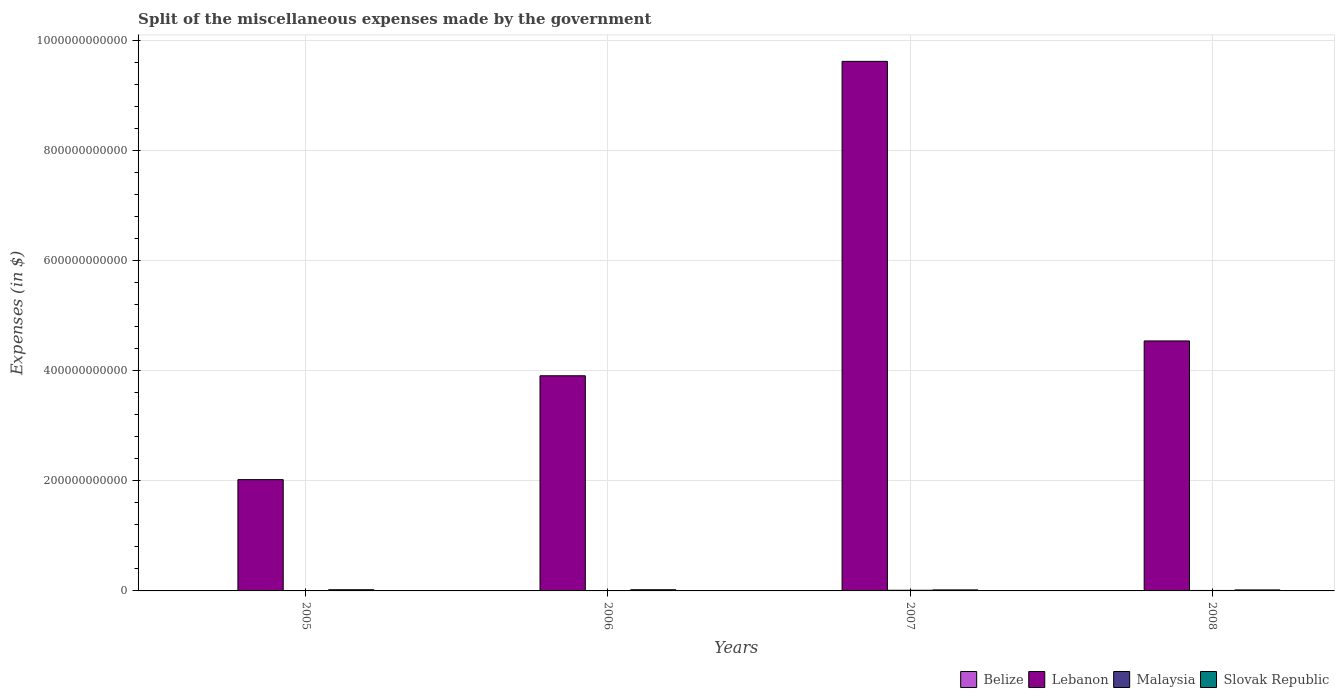How many different coloured bars are there?
Make the answer very short. 4. How many bars are there on the 2nd tick from the left?
Provide a succinct answer. 4. How many bars are there on the 4th tick from the right?
Provide a short and direct response. 4. What is the label of the 2nd group of bars from the left?
Make the answer very short. 2006. In how many cases, is the number of bars for a given year not equal to the number of legend labels?
Offer a terse response. 0. What is the miscellaneous expenses made by the government in Lebanon in 2006?
Offer a very short reply. 3.91e+11. Across all years, what is the maximum miscellaneous expenses made by the government in Slovak Republic?
Your answer should be compact. 2.17e+09. Across all years, what is the minimum miscellaneous expenses made by the government in Malaysia?
Keep it short and to the point. 3.43e+08. In which year was the miscellaneous expenses made by the government in Malaysia minimum?
Give a very brief answer. 2005. What is the total miscellaneous expenses made by the government in Belize in the graph?
Offer a terse response. 7.90e+07. What is the difference between the miscellaneous expenses made by the government in Lebanon in 2005 and that in 2008?
Provide a short and direct response. -2.52e+11. What is the difference between the miscellaneous expenses made by the government in Lebanon in 2007 and the miscellaneous expenses made by the government in Slovak Republic in 2005?
Ensure brevity in your answer.  9.61e+11. What is the average miscellaneous expenses made by the government in Malaysia per year?
Make the answer very short. 6.95e+08. In the year 2008, what is the difference between the miscellaneous expenses made by the government in Belize and miscellaneous expenses made by the government in Slovak Republic?
Your answer should be very brief. -1.83e+09. What is the ratio of the miscellaneous expenses made by the government in Lebanon in 2007 to that in 2008?
Offer a terse response. 2.12. Is the difference between the miscellaneous expenses made by the government in Belize in 2007 and 2008 greater than the difference between the miscellaneous expenses made by the government in Slovak Republic in 2007 and 2008?
Your answer should be very brief. Yes. What is the difference between the highest and the second highest miscellaneous expenses made by the government in Malaysia?
Your response must be concise. 3.48e+08. What is the difference between the highest and the lowest miscellaneous expenses made by the government in Lebanon?
Your answer should be compact. 7.61e+11. In how many years, is the miscellaneous expenses made by the government in Malaysia greater than the average miscellaneous expenses made by the government in Malaysia taken over all years?
Your answer should be very brief. 2. What does the 4th bar from the left in 2007 represents?
Your answer should be compact. Slovak Republic. What does the 1st bar from the right in 2006 represents?
Ensure brevity in your answer.  Slovak Republic. How many bars are there?
Your answer should be very brief. 16. What is the difference between two consecutive major ticks on the Y-axis?
Make the answer very short. 2.00e+11. How many legend labels are there?
Your response must be concise. 4. What is the title of the graph?
Your response must be concise. Split of the miscellaneous expenses made by the government. What is the label or title of the Y-axis?
Offer a terse response. Expenses (in $). What is the Expenses (in $) of Belize in 2005?
Give a very brief answer. 9.38e+06. What is the Expenses (in $) of Lebanon in 2005?
Ensure brevity in your answer.  2.02e+11. What is the Expenses (in $) in Malaysia in 2005?
Your answer should be compact. 3.43e+08. What is the Expenses (in $) in Slovak Republic in 2005?
Your response must be concise. 2.16e+09. What is the Expenses (in $) of Belize in 2006?
Keep it short and to the point. 3.63e+06. What is the Expenses (in $) of Lebanon in 2006?
Offer a terse response. 3.91e+11. What is the Expenses (in $) in Malaysia in 2006?
Your answer should be compact. 3.91e+08. What is the Expenses (in $) in Slovak Republic in 2006?
Ensure brevity in your answer.  2.17e+09. What is the Expenses (in $) of Belize in 2007?
Offer a terse response. 6.27e+07. What is the Expenses (in $) of Lebanon in 2007?
Give a very brief answer. 9.63e+11. What is the Expenses (in $) in Malaysia in 2007?
Provide a succinct answer. 1.20e+09. What is the Expenses (in $) of Slovak Republic in 2007?
Your response must be concise. 1.86e+09. What is the Expenses (in $) of Belize in 2008?
Your response must be concise. 3.21e+06. What is the Expenses (in $) of Lebanon in 2008?
Provide a succinct answer. 4.55e+11. What is the Expenses (in $) in Malaysia in 2008?
Provide a short and direct response. 8.49e+08. What is the Expenses (in $) in Slovak Republic in 2008?
Give a very brief answer. 1.84e+09. Across all years, what is the maximum Expenses (in $) in Belize?
Make the answer very short. 6.27e+07. Across all years, what is the maximum Expenses (in $) in Lebanon?
Offer a terse response. 9.63e+11. Across all years, what is the maximum Expenses (in $) of Malaysia?
Provide a short and direct response. 1.20e+09. Across all years, what is the maximum Expenses (in $) in Slovak Republic?
Make the answer very short. 2.17e+09. Across all years, what is the minimum Expenses (in $) of Belize?
Give a very brief answer. 3.21e+06. Across all years, what is the minimum Expenses (in $) in Lebanon?
Provide a succinct answer. 2.02e+11. Across all years, what is the minimum Expenses (in $) of Malaysia?
Keep it short and to the point. 3.43e+08. Across all years, what is the minimum Expenses (in $) of Slovak Republic?
Offer a terse response. 1.84e+09. What is the total Expenses (in $) in Belize in the graph?
Provide a succinct answer. 7.90e+07. What is the total Expenses (in $) in Lebanon in the graph?
Your answer should be compact. 2.01e+12. What is the total Expenses (in $) of Malaysia in the graph?
Offer a very short reply. 2.78e+09. What is the total Expenses (in $) in Slovak Republic in the graph?
Offer a very short reply. 8.03e+09. What is the difference between the Expenses (in $) of Belize in 2005 and that in 2006?
Ensure brevity in your answer.  5.75e+06. What is the difference between the Expenses (in $) of Lebanon in 2005 and that in 2006?
Provide a short and direct response. -1.89e+11. What is the difference between the Expenses (in $) in Malaysia in 2005 and that in 2006?
Your answer should be very brief. -4.78e+07. What is the difference between the Expenses (in $) of Slovak Republic in 2005 and that in 2006?
Provide a short and direct response. -7.93e+06. What is the difference between the Expenses (in $) of Belize in 2005 and that in 2007?
Your answer should be compact. -5.34e+07. What is the difference between the Expenses (in $) of Lebanon in 2005 and that in 2007?
Offer a very short reply. -7.61e+11. What is the difference between the Expenses (in $) of Malaysia in 2005 and that in 2007?
Ensure brevity in your answer.  -8.54e+08. What is the difference between the Expenses (in $) in Slovak Republic in 2005 and that in 2007?
Make the answer very short. 2.95e+08. What is the difference between the Expenses (in $) in Belize in 2005 and that in 2008?
Your response must be concise. 6.17e+06. What is the difference between the Expenses (in $) of Lebanon in 2005 and that in 2008?
Give a very brief answer. -2.52e+11. What is the difference between the Expenses (in $) of Malaysia in 2005 and that in 2008?
Your answer should be very brief. -5.06e+08. What is the difference between the Expenses (in $) in Slovak Republic in 2005 and that in 2008?
Ensure brevity in your answer.  3.24e+08. What is the difference between the Expenses (in $) in Belize in 2006 and that in 2007?
Make the answer very short. -5.91e+07. What is the difference between the Expenses (in $) in Lebanon in 2006 and that in 2007?
Your answer should be very brief. -5.72e+11. What is the difference between the Expenses (in $) of Malaysia in 2006 and that in 2007?
Your answer should be compact. -8.07e+08. What is the difference between the Expenses (in $) in Slovak Republic in 2006 and that in 2007?
Offer a very short reply. 3.03e+08. What is the difference between the Expenses (in $) in Belize in 2006 and that in 2008?
Keep it short and to the point. 4.26e+05. What is the difference between the Expenses (in $) in Lebanon in 2006 and that in 2008?
Your response must be concise. -6.33e+1. What is the difference between the Expenses (in $) in Malaysia in 2006 and that in 2008?
Provide a succinct answer. -4.58e+08. What is the difference between the Expenses (in $) of Slovak Republic in 2006 and that in 2008?
Give a very brief answer. 3.32e+08. What is the difference between the Expenses (in $) in Belize in 2007 and that in 2008?
Your response must be concise. 5.95e+07. What is the difference between the Expenses (in $) of Lebanon in 2007 and that in 2008?
Provide a succinct answer. 5.08e+11. What is the difference between the Expenses (in $) in Malaysia in 2007 and that in 2008?
Provide a short and direct response. 3.48e+08. What is the difference between the Expenses (in $) in Slovak Republic in 2007 and that in 2008?
Give a very brief answer. 2.90e+07. What is the difference between the Expenses (in $) in Belize in 2005 and the Expenses (in $) in Lebanon in 2006?
Your answer should be very brief. -3.91e+11. What is the difference between the Expenses (in $) in Belize in 2005 and the Expenses (in $) in Malaysia in 2006?
Your response must be concise. -3.81e+08. What is the difference between the Expenses (in $) of Belize in 2005 and the Expenses (in $) of Slovak Republic in 2006?
Your answer should be very brief. -2.16e+09. What is the difference between the Expenses (in $) in Lebanon in 2005 and the Expenses (in $) in Malaysia in 2006?
Ensure brevity in your answer.  2.02e+11. What is the difference between the Expenses (in $) in Lebanon in 2005 and the Expenses (in $) in Slovak Republic in 2006?
Offer a terse response. 2.00e+11. What is the difference between the Expenses (in $) in Malaysia in 2005 and the Expenses (in $) in Slovak Republic in 2006?
Keep it short and to the point. -1.82e+09. What is the difference between the Expenses (in $) of Belize in 2005 and the Expenses (in $) of Lebanon in 2007?
Give a very brief answer. -9.63e+11. What is the difference between the Expenses (in $) of Belize in 2005 and the Expenses (in $) of Malaysia in 2007?
Your response must be concise. -1.19e+09. What is the difference between the Expenses (in $) of Belize in 2005 and the Expenses (in $) of Slovak Republic in 2007?
Ensure brevity in your answer.  -1.86e+09. What is the difference between the Expenses (in $) of Lebanon in 2005 and the Expenses (in $) of Malaysia in 2007?
Keep it short and to the point. 2.01e+11. What is the difference between the Expenses (in $) of Lebanon in 2005 and the Expenses (in $) of Slovak Republic in 2007?
Your answer should be compact. 2.00e+11. What is the difference between the Expenses (in $) in Malaysia in 2005 and the Expenses (in $) in Slovak Republic in 2007?
Your answer should be very brief. -1.52e+09. What is the difference between the Expenses (in $) of Belize in 2005 and the Expenses (in $) of Lebanon in 2008?
Your response must be concise. -4.55e+11. What is the difference between the Expenses (in $) of Belize in 2005 and the Expenses (in $) of Malaysia in 2008?
Provide a succinct answer. -8.40e+08. What is the difference between the Expenses (in $) in Belize in 2005 and the Expenses (in $) in Slovak Republic in 2008?
Give a very brief answer. -1.83e+09. What is the difference between the Expenses (in $) of Lebanon in 2005 and the Expenses (in $) of Malaysia in 2008?
Your response must be concise. 2.01e+11. What is the difference between the Expenses (in $) of Lebanon in 2005 and the Expenses (in $) of Slovak Republic in 2008?
Your answer should be very brief. 2.00e+11. What is the difference between the Expenses (in $) of Malaysia in 2005 and the Expenses (in $) of Slovak Republic in 2008?
Make the answer very short. -1.49e+09. What is the difference between the Expenses (in $) in Belize in 2006 and the Expenses (in $) in Lebanon in 2007?
Keep it short and to the point. -9.63e+11. What is the difference between the Expenses (in $) of Belize in 2006 and the Expenses (in $) of Malaysia in 2007?
Your answer should be compact. -1.19e+09. What is the difference between the Expenses (in $) in Belize in 2006 and the Expenses (in $) in Slovak Republic in 2007?
Give a very brief answer. -1.86e+09. What is the difference between the Expenses (in $) of Lebanon in 2006 and the Expenses (in $) of Malaysia in 2007?
Ensure brevity in your answer.  3.90e+11. What is the difference between the Expenses (in $) of Lebanon in 2006 and the Expenses (in $) of Slovak Republic in 2007?
Keep it short and to the point. 3.89e+11. What is the difference between the Expenses (in $) in Malaysia in 2006 and the Expenses (in $) in Slovak Republic in 2007?
Your answer should be very brief. -1.47e+09. What is the difference between the Expenses (in $) in Belize in 2006 and the Expenses (in $) in Lebanon in 2008?
Offer a very short reply. -4.55e+11. What is the difference between the Expenses (in $) in Belize in 2006 and the Expenses (in $) in Malaysia in 2008?
Keep it short and to the point. -8.46e+08. What is the difference between the Expenses (in $) of Belize in 2006 and the Expenses (in $) of Slovak Republic in 2008?
Provide a short and direct response. -1.83e+09. What is the difference between the Expenses (in $) in Lebanon in 2006 and the Expenses (in $) in Malaysia in 2008?
Provide a short and direct response. 3.90e+11. What is the difference between the Expenses (in $) of Lebanon in 2006 and the Expenses (in $) of Slovak Republic in 2008?
Your answer should be very brief. 3.89e+11. What is the difference between the Expenses (in $) of Malaysia in 2006 and the Expenses (in $) of Slovak Republic in 2008?
Your answer should be compact. -1.44e+09. What is the difference between the Expenses (in $) of Belize in 2007 and the Expenses (in $) of Lebanon in 2008?
Your answer should be very brief. -4.54e+11. What is the difference between the Expenses (in $) of Belize in 2007 and the Expenses (in $) of Malaysia in 2008?
Provide a short and direct response. -7.86e+08. What is the difference between the Expenses (in $) in Belize in 2007 and the Expenses (in $) in Slovak Republic in 2008?
Provide a short and direct response. -1.77e+09. What is the difference between the Expenses (in $) in Lebanon in 2007 and the Expenses (in $) in Malaysia in 2008?
Provide a short and direct response. 9.62e+11. What is the difference between the Expenses (in $) in Lebanon in 2007 and the Expenses (in $) in Slovak Republic in 2008?
Keep it short and to the point. 9.61e+11. What is the difference between the Expenses (in $) in Malaysia in 2007 and the Expenses (in $) in Slovak Republic in 2008?
Ensure brevity in your answer.  -6.38e+08. What is the average Expenses (in $) in Belize per year?
Make the answer very short. 1.97e+07. What is the average Expenses (in $) of Lebanon per year?
Your response must be concise. 5.03e+11. What is the average Expenses (in $) in Malaysia per year?
Give a very brief answer. 6.95e+08. What is the average Expenses (in $) of Slovak Republic per year?
Your answer should be compact. 2.01e+09. In the year 2005, what is the difference between the Expenses (in $) in Belize and Expenses (in $) in Lebanon?
Ensure brevity in your answer.  -2.02e+11. In the year 2005, what is the difference between the Expenses (in $) of Belize and Expenses (in $) of Malaysia?
Make the answer very short. -3.34e+08. In the year 2005, what is the difference between the Expenses (in $) of Belize and Expenses (in $) of Slovak Republic?
Give a very brief answer. -2.15e+09. In the year 2005, what is the difference between the Expenses (in $) of Lebanon and Expenses (in $) of Malaysia?
Your answer should be very brief. 2.02e+11. In the year 2005, what is the difference between the Expenses (in $) of Lebanon and Expenses (in $) of Slovak Republic?
Keep it short and to the point. 2.00e+11. In the year 2005, what is the difference between the Expenses (in $) in Malaysia and Expenses (in $) in Slovak Republic?
Ensure brevity in your answer.  -1.82e+09. In the year 2006, what is the difference between the Expenses (in $) of Belize and Expenses (in $) of Lebanon?
Provide a short and direct response. -3.91e+11. In the year 2006, what is the difference between the Expenses (in $) in Belize and Expenses (in $) in Malaysia?
Provide a short and direct response. -3.87e+08. In the year 2006, what is the difference between the Expenses (in $) in Belize and Expenses (in $) in Slovak Republic?
Offer a terse response. -2.16e+09. In the year 2006, what is the difference between the Expenses (in $) in Lebanon and Expenses (in $) in Malaysia?
Give a very brief answer. 3.91e+11. In the year 2006, what is the difference between the Expenses (in $) in Lebanon and Expenses (in $) in Slovak Republic?
Offer a very short reply. 3.89e+11. In the year 2006, what is the difference between the Expenses (in $) of Malaysia and Expenses (in $) of Slovak Republic?
Ensure brevity in your answer.  -1.78e+09. In the year 2007, what is the difference between the Expenses (in $) in Belize and Expenses (in $) in Lebanon?
Ensure brevity in your answer.  -9.63e+11. In the year 2007, what is the difference between the Expenses (in $) in Belize and Expenses (in $) in Malaysia?
Your response must be concise. -1.13e+09. In the year 2007, what is the difference between the Expenses (in $) of Belize and Expenses (in $) of Slovak Republic?
Your answer should be compact. -1.80e+09. In the year 2007, what is the difference between the Expenses (in $) in Lebanon and Expenses (in $) in Malaysia?
Your answer should be compact. 9.62e+11. In the year 2007, what is the difference between the Expenses (in $) of Lebanon and Expenses (in $) of Slovak Republic?
Provide a succinct answer. 9.61e+11. In the year 2007, what is the difference between the Expenses (in $) of Malaysia and Expenses (in $) of Slovak Republic?
Give a very brief answer. -6.67e+08. In the year 2008, what is the difference between the Expenses (in $) of Belize and Expenses (in $) of Lebanon?
Your answer should be compact. -4.55e+11. In the year 2008, what is the difference between the Expenses (in $) of Belize and Expenses (in $) of Malaysia?
Provide a succinct answer. -8.46e+08. In the year 2008, what is the difference between the Expenses (in $) of Belize and Expenses (in $) of Slovak Republic?
Keep it short and to the point. -1.83e+09. In the year 2008, what is the difference between the Expenses (in $) in Lebanon and Expenses (in $) in Malaysia?
Your answer should be very brief. 4.54e+11. In the year 2008, what is the difference between the Expenses (in $) of Lebanon and Expenses (in $) of Slovak Republic?
Provide a succinct answer. 4.53e+11. In the year 2008, what is the difference between the Expenses (in $) of Malaysia and Expenses (in $) of Slovak Republic?
Provide a succinct answer. -9.86e+08. What is the ratio of the Expenses (in $) of Belize in 2005 to that in 2006?
Provide a short and direct response. 2.58. What is the ratio of the Expenses (in $) in Lebanon in 2005 to that in 2006?
Provide a succinct answer. 0.52. What is the ratio of the Expenses (in $) in Malaysia in 2005 to that in 2006?
Provide a succinct answer. 0.88. What is the ratio of the Expenses (in $) of Belize in 2005 to that in 2007?
Provide a succinct answer. 0.15. What is the ratio of the Expenses (in $) of Lebanon in 2005 to that in 2007?
Offer a very short reply. 0.21. What is the ratio of the Expenses (in $) in Malaysia in 2005 to that in 2007?
Provide a succinct answer. 0.29. What is the ratio of the Expenses (in $) of Slovak Republic in 2005 to that in 2007?
Keep it short and to the point. 1.16. What is the ratio of the Expenses (in $) in Belize in 2005 to that in 2008?
Provide a short and direct response. 2.92. What is the ratio of the Expenses (in $) of Lebanon in 2005 to that in 2008?
Keep it short and to the point. 0.45. What is the ratio of the Expenses (in $) in Malaysia in 2005 to that in 2008?
Provide a succinct answer. 0.4. What is the ratio of the Expenses (in $) in Slovak Republic in 2005 to that in 2008?
Offer a terse response. 1.18. What is the ratio of the Expenses (in $) in Belize in 2006 to that in 2007?
Ensure brevity in your answer.  0.06. What is the ratio of the Expenses (in $) in Lebanon in 2006 to that in 2007?
Ensure brevity in your answer.  0.41. What is the ratio of the Expenses (in $) in Malaysia in 2006 to that in 2007?
Make the answer very short. 0.33. What is the ratio of the Expenses (in $) in Slovak Republic in 2006 to that in 2007?
Provide a succinct answer. 1.16. What is the ratio of the Expenses (in $) in Belize in 2006 to that in 2008?
Your answer should be compact. 1.13. What is the ratio of the Expenses (in $) of Lebanon in 2006 to that in 2008?
Keep it short and to the point. 0.86. What is the ratio of the Expenses (in $) in Malaysia in 2006 to that in 2008?
Keep it short and to the point. 0.46. What is the ratio of the Expenses (in $) in Slovak Republic in 2006 to that in 2008?
Ensure brevity in your answer.  1.18. What is the ratio of the Expenses (in $) of Belize in 2007 to that in 2008?
Your answer should be compact. 19.56. What is the ratio of the Expenses (in $) of Lebanon in 2007 to that in 2008?
Keep it short and to the point. 2.12. What is the ratio of the Expenses (in $) of Malaysia in 2007 to that in 2008?
Make the answer very short. 1.41. What is the ratio of the Expenses (in $) in Slovak Republic in 2007 to that in 2008?
Offer a very short reply. 1.02. What is the difference between the highest and the second highest Expenses (in $) in Belize?
Keep it short and to the point. 5.34e+07. What is the difference between the highest and the second highest Expenses (in $) of Lebanon?
Offer a very short reply. 5.08e+11. What is the difference between the highest and the second highest Expenses (in $) of Malaysia?
Give a very brief answer. 3.48e+08. What is the difference between the highest and the second highest Expenses (in $) in Slovak Republic?
Offer a very short reply. 7.93e+06. What is the difference between the highest and the lowest Expenses (in $) of Belize?
Provide a short and direct response. 5.95e+07. What is the difference between the highest and the lowest Expenses (in $) of Lebanon?
Your response must be concise. 7.61e+11. What is the difference between the highest and the lowest Expenses (in $) in Malaysia?
Offer a terse response. 8.54e+08. What is the difference between the highest and the lowest Expenses (in $) of Slovak Republic?
Your answer should be very brief. 3.32e+08. 